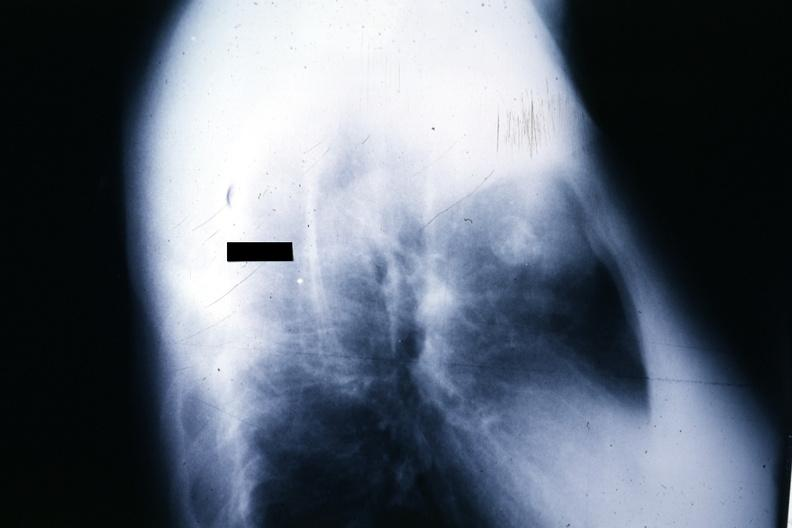s thymoma present?
Answer the question using a single word or phrase. Yes 